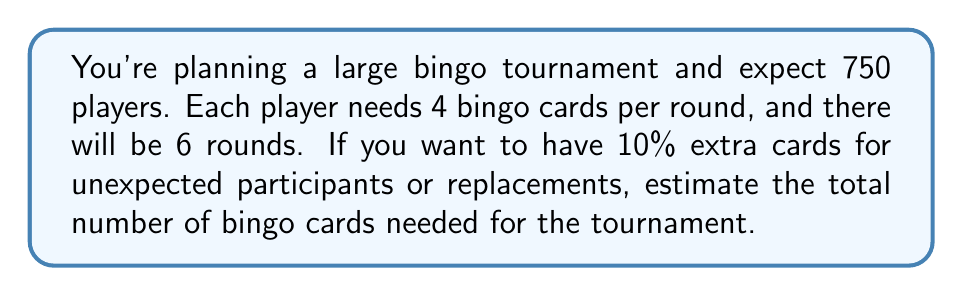Provide a solution to this math problem. Let's break this down step-by-step:

1. Calculate the number of cards needed per player for all rounds:
   $4 \text{ cards per round} \times 6 \text{ rounds} = 24 \text{ cards per player}$

2. Calculate the total number of cards needed for all expected players:
   $750 \text{ players} \times 24 \text{ cards per player} = 18,000 \text{ cards}$

3. Calculate 10% extra cards:
   $18,000 \times 0.10 = 1,800 \text{ extra cards}$

4. Sum up the total cards needed:
   $18,000 + 1,800 = 19,800 \text{ cards}$

5. Round up to the nearest hundred for a good estimate:
   $19,800 \text{ rounded up} = 19,900 \text{ cards}$

Therefore, you should estimate needing about 19,900 bingo cards for the tournament.
Answer: 19,900 cards 